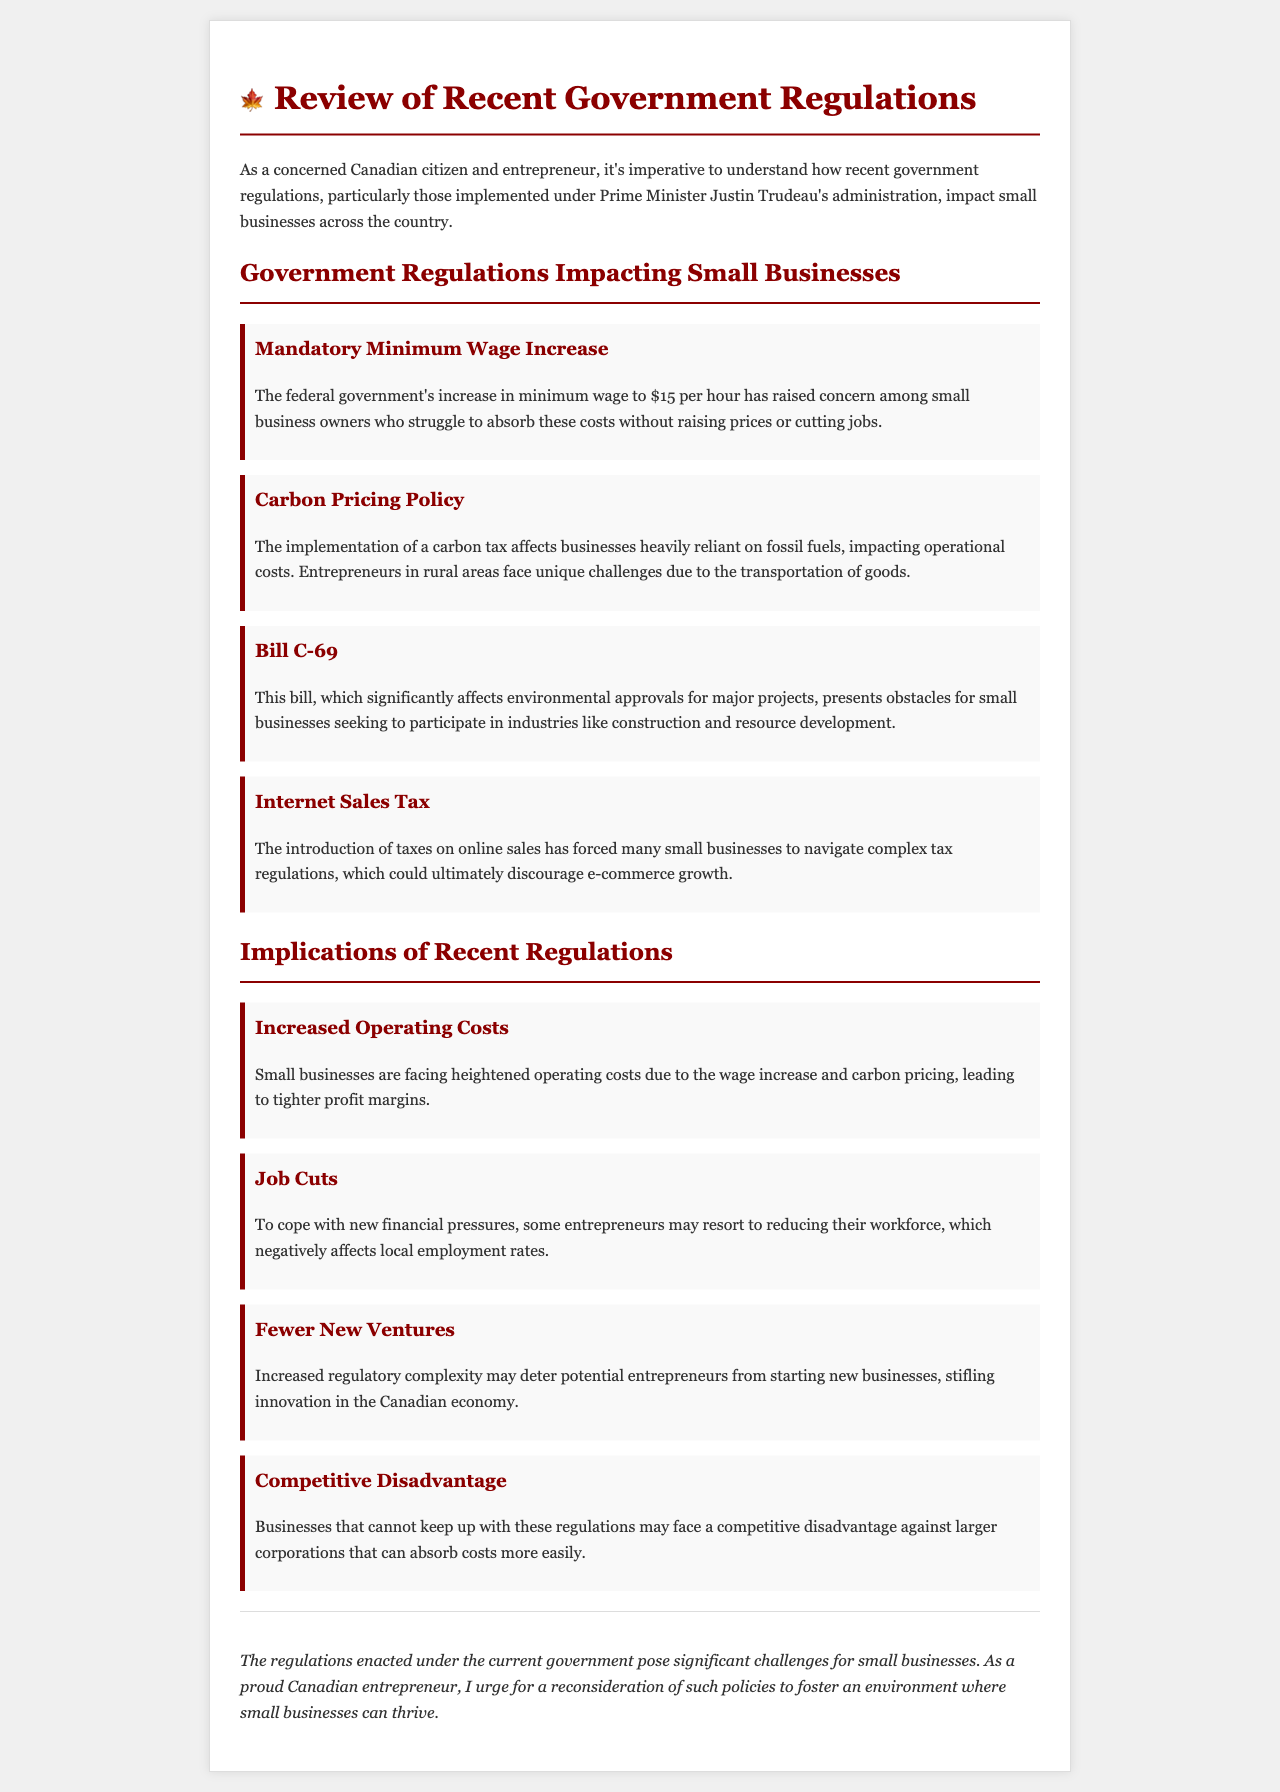What is the minimum wage increase amount? The document states that the federal government's increase in minimum wage is to $15 per hour.
Answer: $15 per hour What is the impact of carbon pricing on businesses? It is mentioned that the carbon tax affects businesses heavily reliant on fossil fuels, impacting operational costs.
Answer: Operational costs Which bill presents obstacles for construction and resource development? The document refers to Bill C-69 as significantly affecting environmental approvals for major projects.
Answer: Bill C-69 What are small businesses struggling to manage due to recent regulations? The text highlights that small businesses are facing increased operating costs due to the wage increase and carbon pricing.
Answer: Increased operating costs What consequence might small businesses face as a reaction to financial pressures? The document indicates that business owners may resort to reducing their workforce.
Answer: Job cuts What is one implication of increased regulatory complexity mentioned in the letter? It notes that it may deter potential entrepreneurs from starting new businesses, stifling innovation.
Answer: Fewer new ventures What is the overall sentiment expressed regarding these regulations? The conclusion urges reconsideration of such policies to foster an environment where small businesses can thrive.
Answer: Urgent reconsideration How do smaller businesses compare to larger corporations in absorbing costs according to the document? The document states that businesses unable to keep up may face a competitive disadvantage against larger corporations.
Answer: Competitive disadvantage 